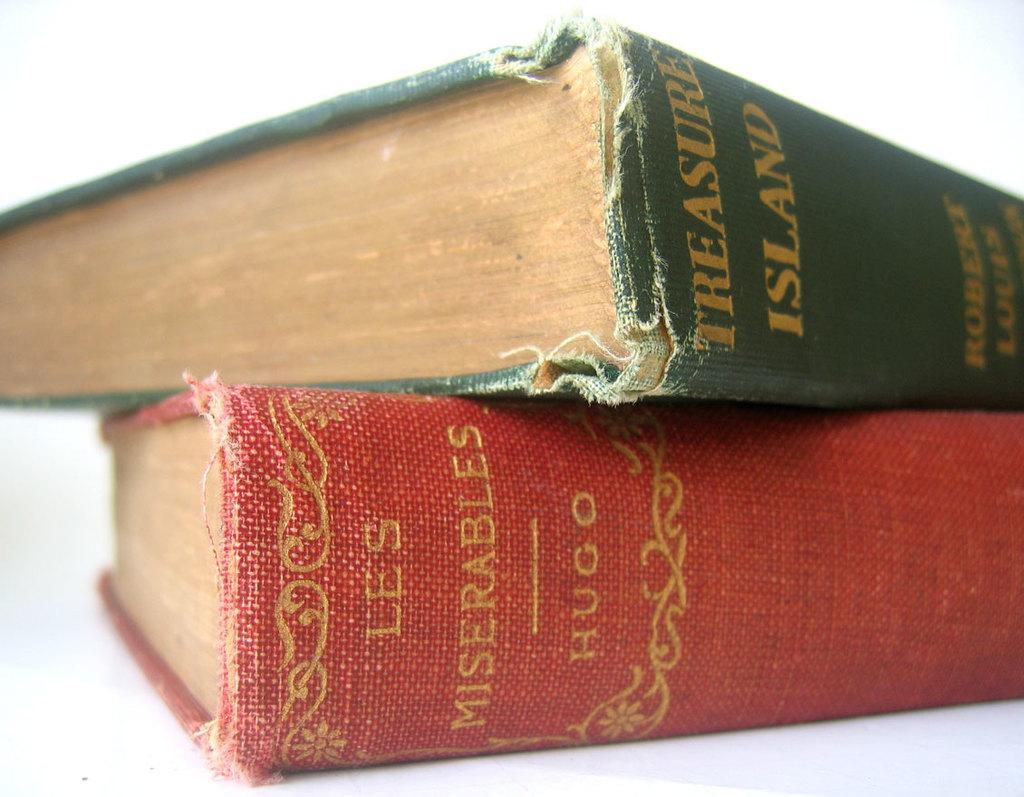<image>
Describe the image concisely. Two vintage books that are les miserables and treasure island 